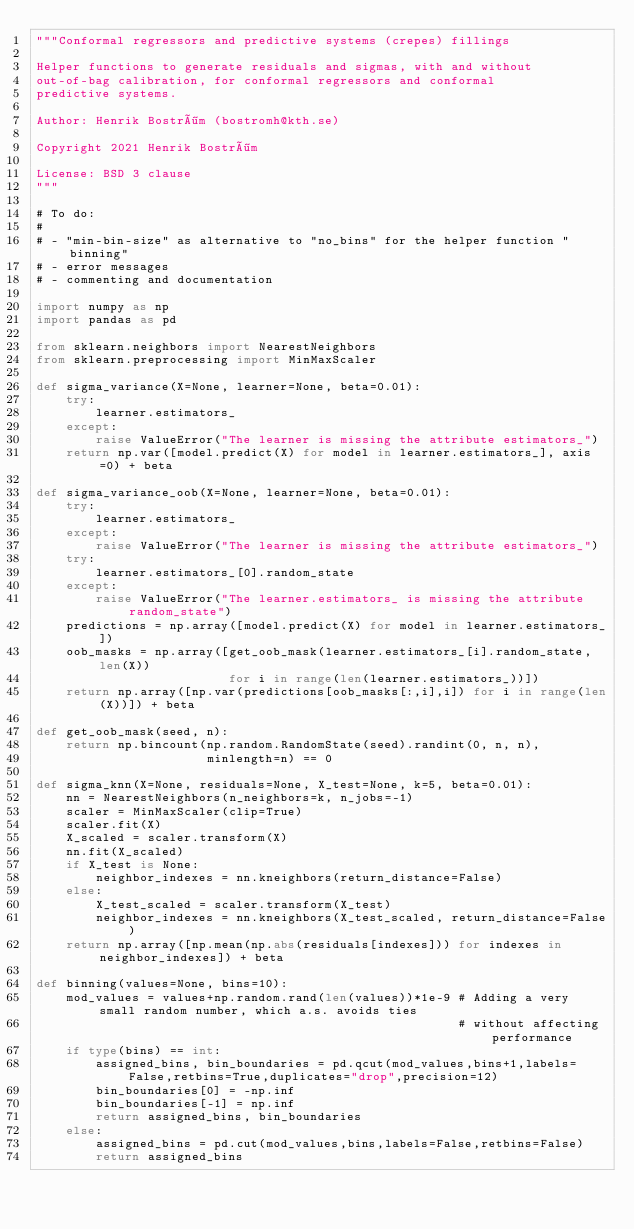Convert code to text. <code><loc_0><loc_0><loc_500><loc_500><_Python_>"""Conformal regressors and predictive systems (crepes) fillings

Helper functions to generate residuals and sigmas, with and without
out-of-bag calibration, for conformal regressors and conformal
predictive systems.

Author: Henrik Boström (bostromh@kth.se)

Copyright 2021 Henrik Boström

License: BSD 3 clause
"""

# To do:
#
# - "min-bin-size" as alternative to "no_bins" for the helper function "binning"
# - error messages
# - commenting and documentation 

import numpy as np
import pandas as pd

from sklearn.neighbors import NearestNeighbors
from sklearn.preprocessing import MinMaxScaler

def sigma_variance(X=None, learner=None, beta=0.01):
    try:
        learner.estimators_
    except:
        raise ValueError("The learner is missing the attribute estimators_")
    return np.var([model.predict(X) for model in learner.estimators_], axis=0) + beta

def sigma_variance_oob(X=None, learner=None, beta=0.01):
    try:
        learner.estimators_
    except:
        raise ValueError("The learner is missing the attribute estimators_")
    try:
        learner.estimators_[0].random_state
    except:
        raise ValueError("The learner.estimators_ is missing the attribute random_state")
    predictions = np.array([model.predict(X) for model in learner.estimators_])
    oob_masks = np.array([get_oob_mask(learner.estimators_[i].random_state,len(X))
                          for i in range(len(learner.estimators_))])
    return np.array([np.var(predictions[oob_masks[:,i],i]) for i in range(len(X))]) + beta

def get_oob_mask(seed, n):
    return np.bincount(np.random.RandomState(seed).randint(0, n, n),
                       minlength=n) == 0

def sigma_knn(X=None, residuals=None, X_test=None, k=5, beta=0.01):
    nn = NearestNeighbors(n_neighbors=k, n_jobs=-1)
    scaler = MinMaxScaler(clip=True)
    scaler.fit(X)
    X_scaled = scaler.transform(X)
    nn.fit(X_scaled)
    if X_test is None:
        neighbor_indexes = nn.kneighbors(return_distance=False)
    else:
        X_test_scaled = scaler.transform(X_test)
        neighbor_indexes = nn.kneighbors(X_test_scaled, return_distance=False)
    return np.array([np.mean(np.abs(residuals[indexes])) for indexes in neighbor_indexes]) + beta

def binning(values=None, bins=10):
    mod_values = values+np.random.rand(len(values))*1e-9 # Adding a very small random number, which a.s. avoids ties
                                                         # without affecting performance
    if type(bins) == int:
        assigned_bins, bin_boundaries = pd.qcut(mod_values,bins+1,labels=False,retbins=True,duplicates="drop",precision=12)
        bin_boundaries[0] = -np.inf
        bin_boundaries[-1] = np.inf
        return assigned_bins, bin_boundaries
    else:
        assigned_bins = pd.cut(mod_values,bins,labels=False,retbins=False)
        return assigned_bins
</code> 